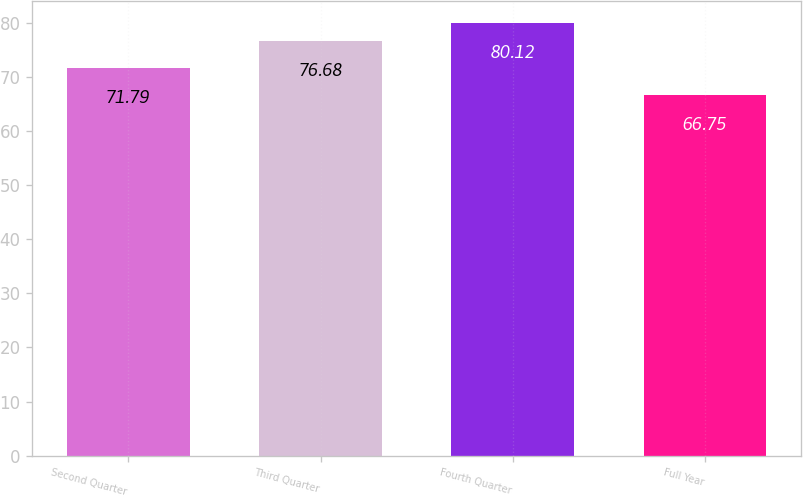<chart> <loc_0><loc_0><loc_500><loc_500><bar_chart><fcel>Second Quarter<fcel>Third Quarter<fcel>Fourth Quarter<fcel>Full Year<nl><fcel>71.79<fcel>76.68<fcel>80.12<fcel>66.75<nl></chart> 